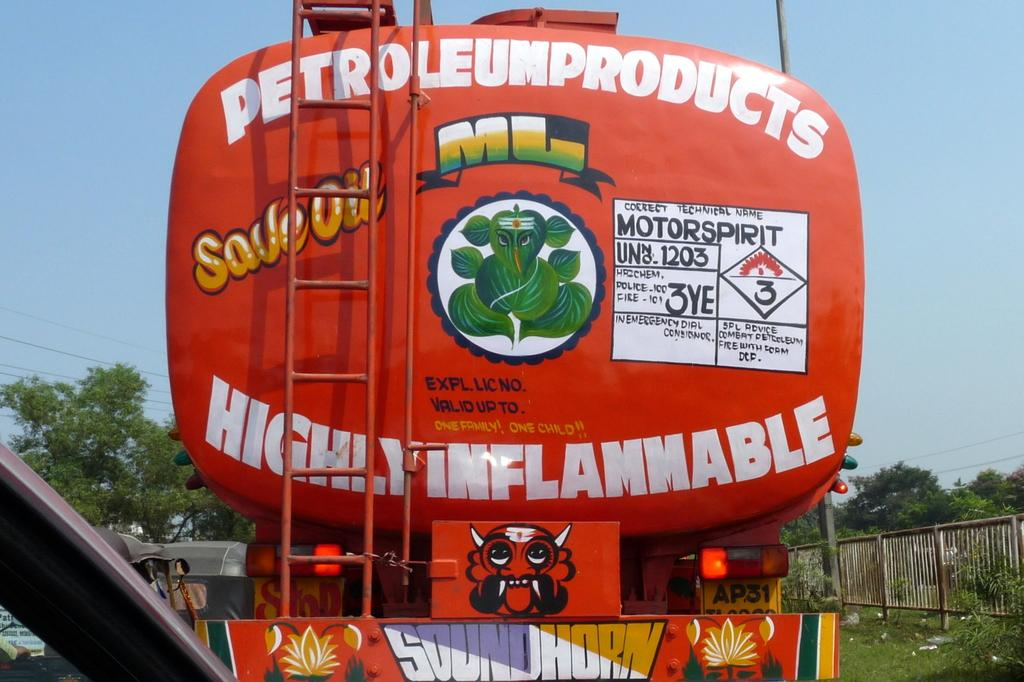What types of objects are present in the image? There are vehicles in the image. What type of natural environment can be seen in the image? There is grass, plants, trees, and the sky visible in the image. What structures are present in the image? There is a fence in the image. What else can be seen in the background of the image? There are wires in the background of the image. How many cows are grazing in the grass in the image? There are no cows present in the image; it features vehicles, grass, plants, trees, a fence, wires, and the sky. What type of voyage is depicted in the image? There is no voyage depicted in the image; it shows vehicles, grass, plants, trees, a fence, wires, and the sky. 